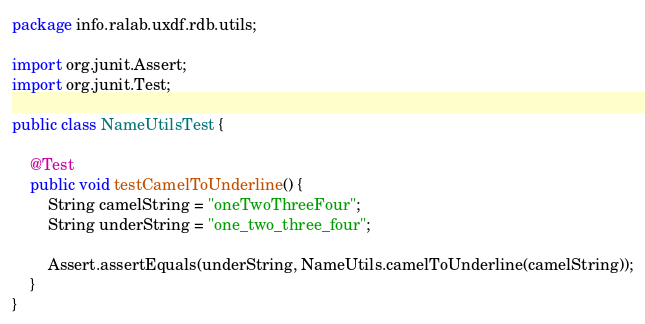<code> <loc_0><loc_0><loc_500><loc_500><_Java_>package info.ralab.uxdf.rdb.utils;

import org.junit.Assert;
import org.junit.Test;

public class NameUtilsTest {

    @Test
    public void testCamelToUnderline() {
        String camelString = "oneTwoThreeFour";
        String underString = "one_two_three_four";

        Assert.assertEquals(underString, NameUtils.camelToUnderline(camelString));
    }
}
</code> 